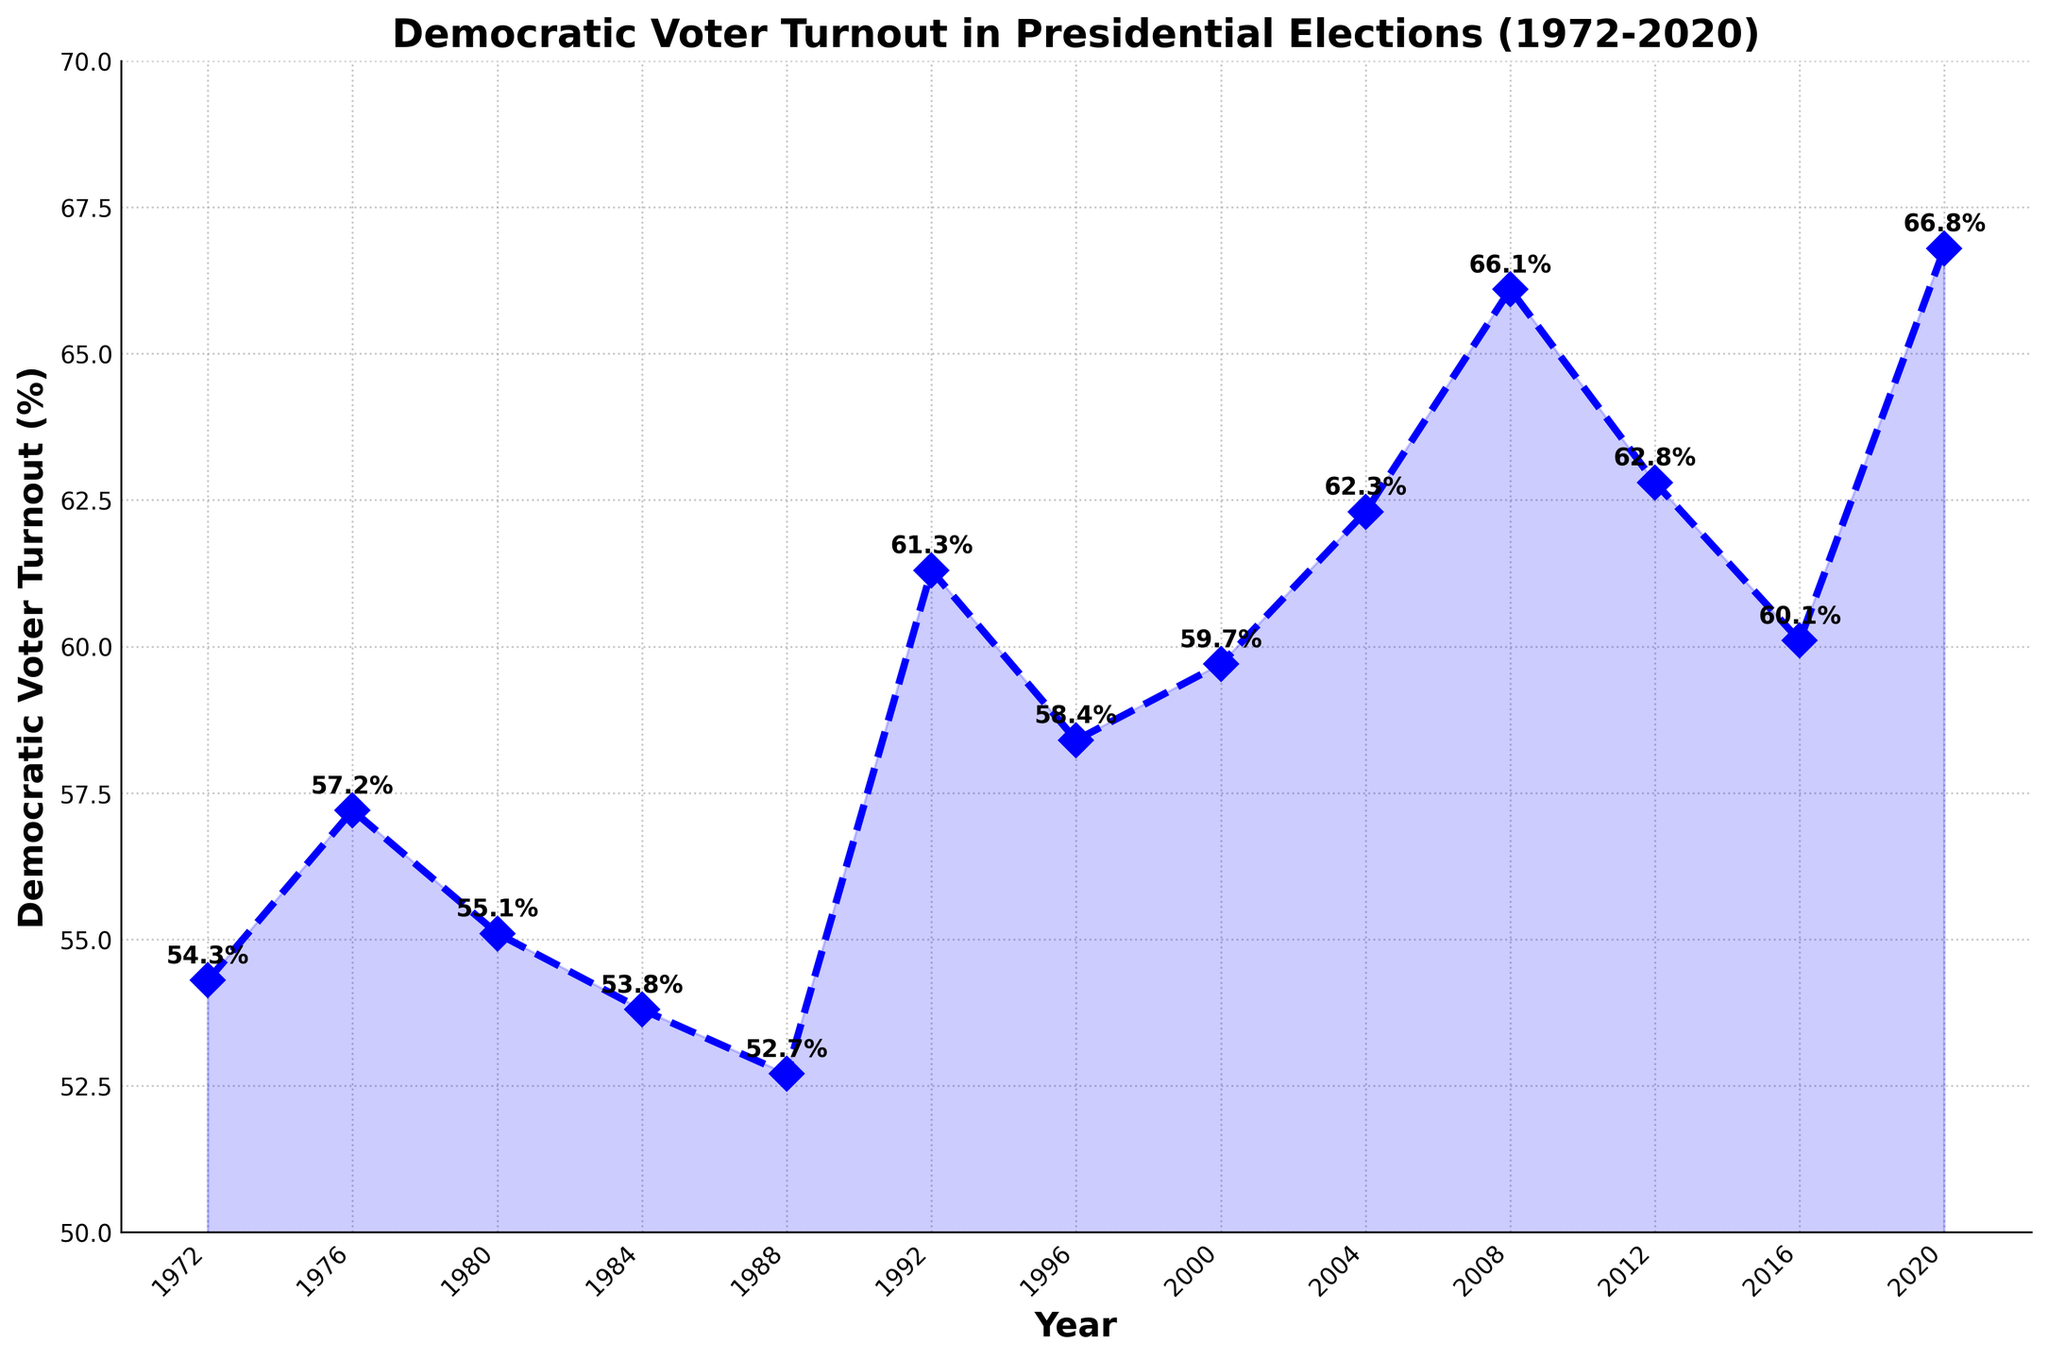what is the highest Democratic voter turnout in the past 50 years? Looking at the highest point on the graph, it is around the year 2020 where the turnout hits 66.8%.
Answer: 66.8% which year showed the lowest Democratic voter turnout? The lowest point on the graph is around the year 1988, where the turnout hits 52.7%.
Answer: 1988 did the Democratic voter turnout increase or decrease between 2008 and 2012? By comparing the heights of the points, the 2008 turnout is 66.1% and the 2012 turnout is 62.8%, indicating a decrease.
Answer: decrease what is the average Democratic voter turnout from 1972 to 2020? To get the average, sum all the turnout values and divide by the number of data points: (54.3 + 57.2 + 55.1 + 53.8 + 52.7 + 61.3 + 58.4 + 59.7 + 62.3 + 66.1 + 62.8 + 60.1 + 66.8) / 13 = 59.7%.
Answer: 59.7% how many years had a voter turnout above 60%? Count each point above the 60% line on the graph. The years are 1992, 2004, 2008, 2012, 2016, and 2020.
Answer: 6 Compare the Democratic voter turnout in 1976 and 2016. Which year had a higher turnout? By examining the points, the year 1976 has a turnout of 57.2%, and 2016 has a turnout of 60.1%, indicating 2016 had a higher turnout.
Answer: 2016 what is the total change in Democratic voter turnout from 1972 to 2020? Calculate the difference between the 1972 and 2020 values: 66.8% - 54.3% = 12.5%.
Answer: 12.5% What trend can be observed from the voter turnout between 1988 and 1992? Observing the line, there is a noticeable increase from 52.7% in 1988 to 61.3% in 1992.
Answer: increase What is the voter turnout in the year 2000, and how does it compare to the voter turnout in 1996? The 2000 turnout is 59.7%, and the 1996 turnout is 58.4%. By comparison, 2000 had a higher turnout than 1996.
Answer: 59.7%, higher 